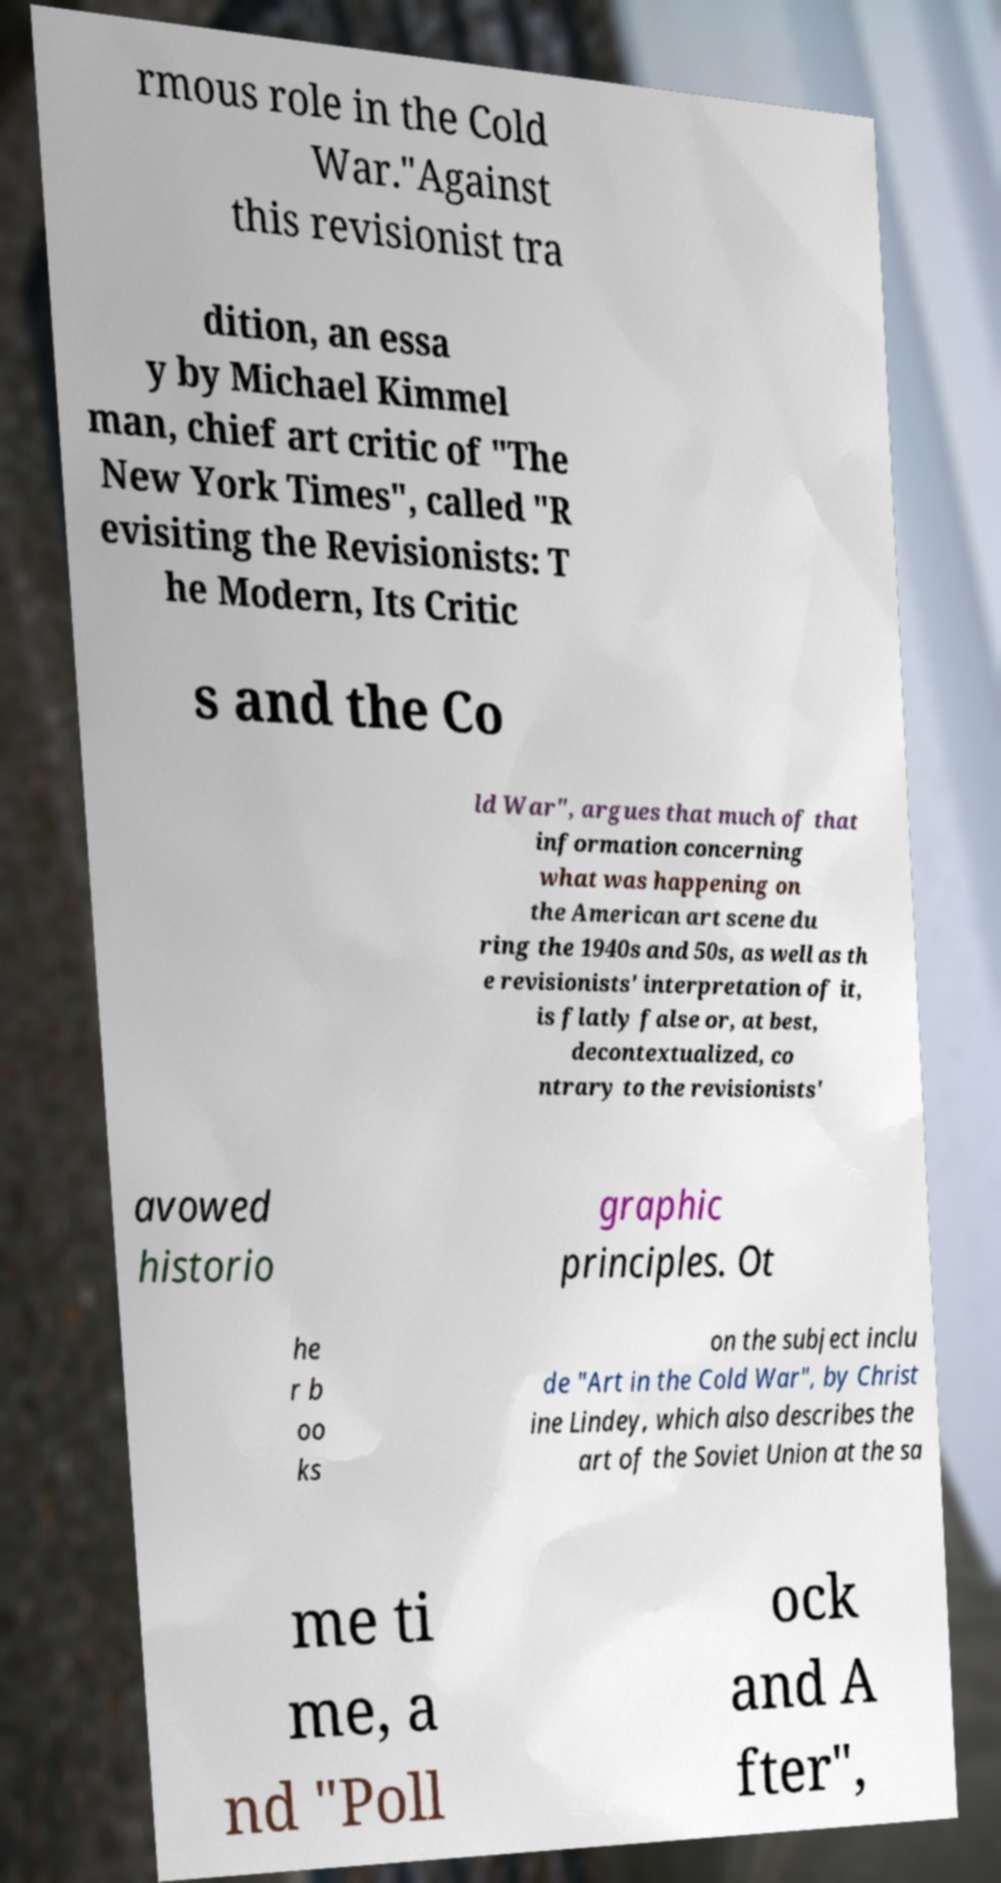Can you read and provide the text displayed in the image?This photo seems to have some interesting text. Can you extract and type it out for me? rmous role in the Cold War."Against this revisionist tra dition, an essa y by Michael Kimmel man, chief art critic of "The New York Times", called "R evisiting the Revisionists: T he Modern, Its Critic s and the Co ld War", argues that much of that information concerning what was happening on the American art scene du ring the 1940s and 50s, as well as th e revisionists' interpretation of it, is flatly false or, at best, decontextualized, co ntrary to the revisionists' avowed historio graphic principles. Ot he r b oo ks on the subject inclu de "Art in the Cold War", by Christ ine Lindey, which also describes the art of the Soviet Union at the sa me ti me, a nd "Poll ock and A fter", 